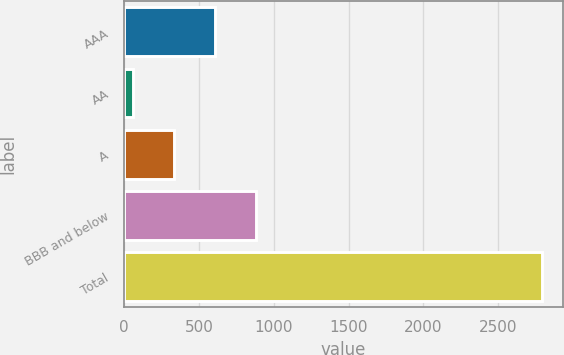Convert chart. <chart><loc_0><loc_0><loc_500><loc_500><bar_chart><fcel>AAA<fcel>AA<fcel>A<fcel>BBB and below<fcel>Total<nl><fcel>605<fcel>58<fcel>331.5<fcel>878.5<fcel>2793<nl></chart> 